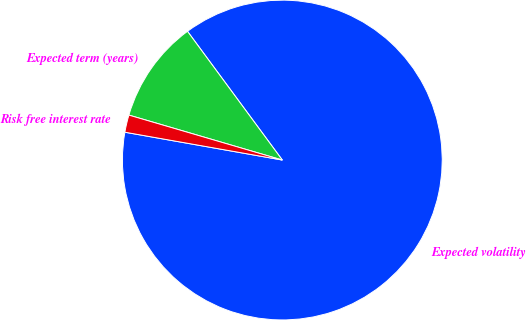Convert chart to OTSL. <chart><loc_0><loc_0><loc_500><loc_500><pie_chart><fcel>Expected volatility<fcel>Expected term (years)<fcel>Risk free interest rate<nl><fcel>87.89%<fcel>10.36%<fcel>1.75%<nl></chart> 